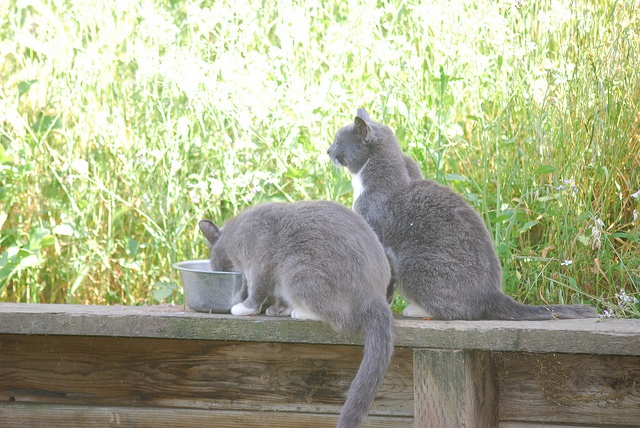Describe the objects in this image and their specific colors. I can see cat in ivory, darkgray, and gray tones, cat in ivory, gray, and white tones, and bowl in ivory, darkgray, gray, and lavender tones in this image. 